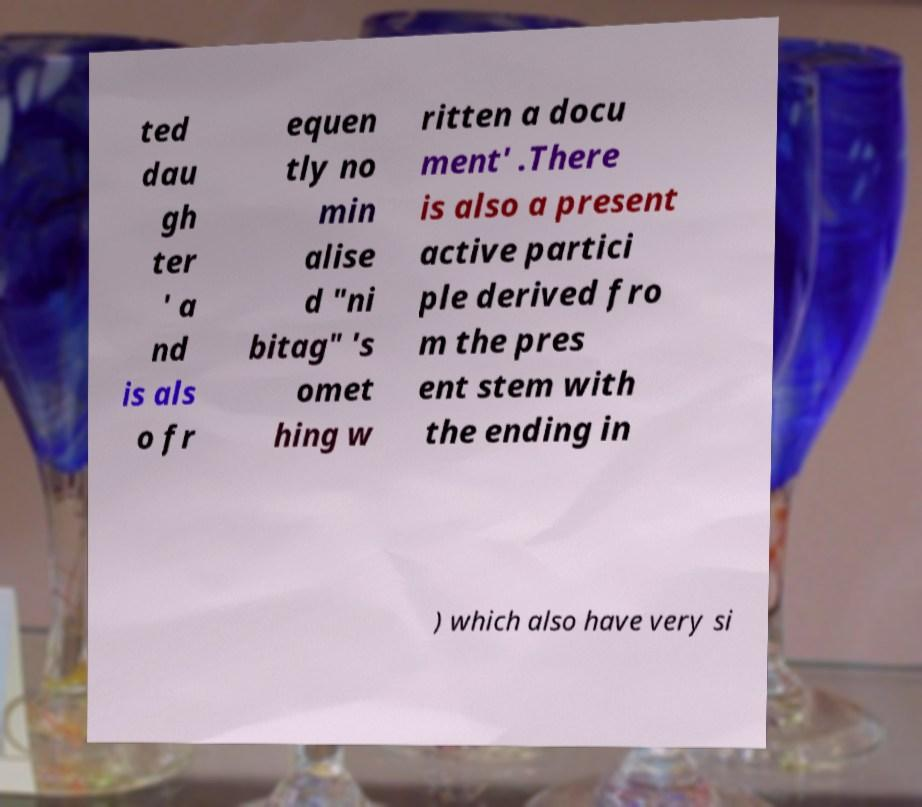For documentation purposes, I need the text within this image transcribed. Could you provide that? ted dau gh ter ' a nd is als o fr equen tly no min alise d "ni bitag" 's omet hing w ritten a docu ment' .There is also a present active partici ple derived fro m the pres ent stem with the ending in ) which also have very si 